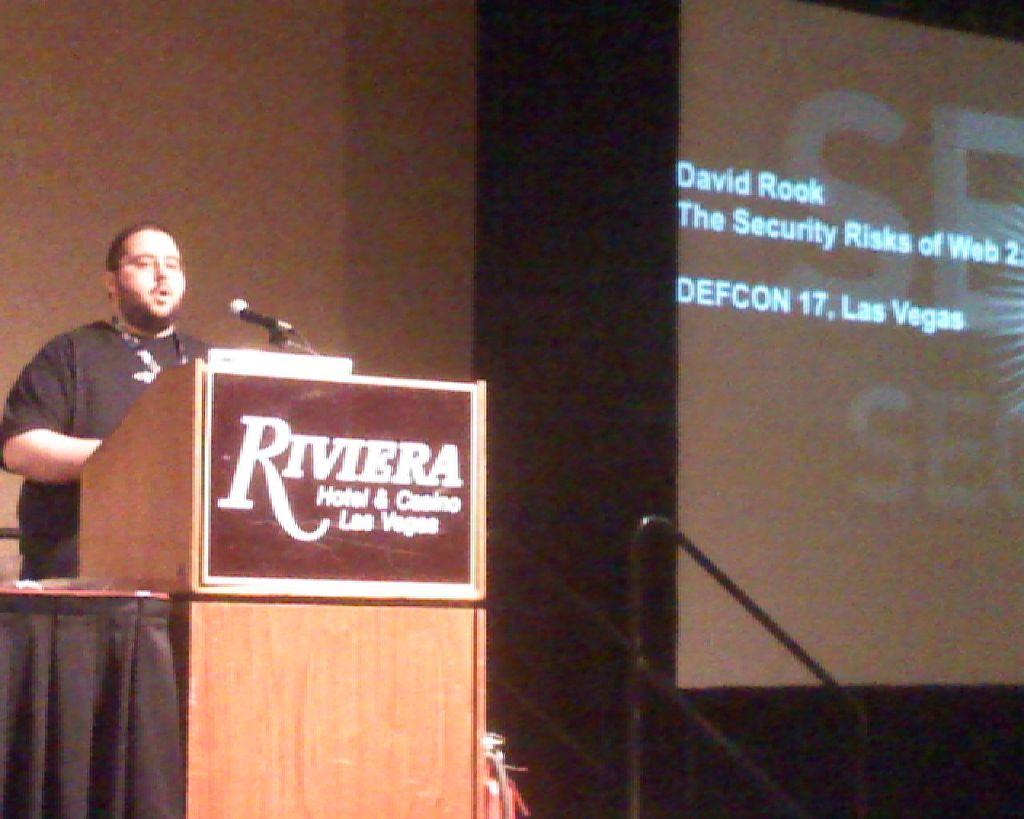Can you describe this image briefly? In this picture we can see a person standing on the left side. We can see a mic and a podium. There is a black cloth on the podium. There is a screen on the right side. We can see a stand. 